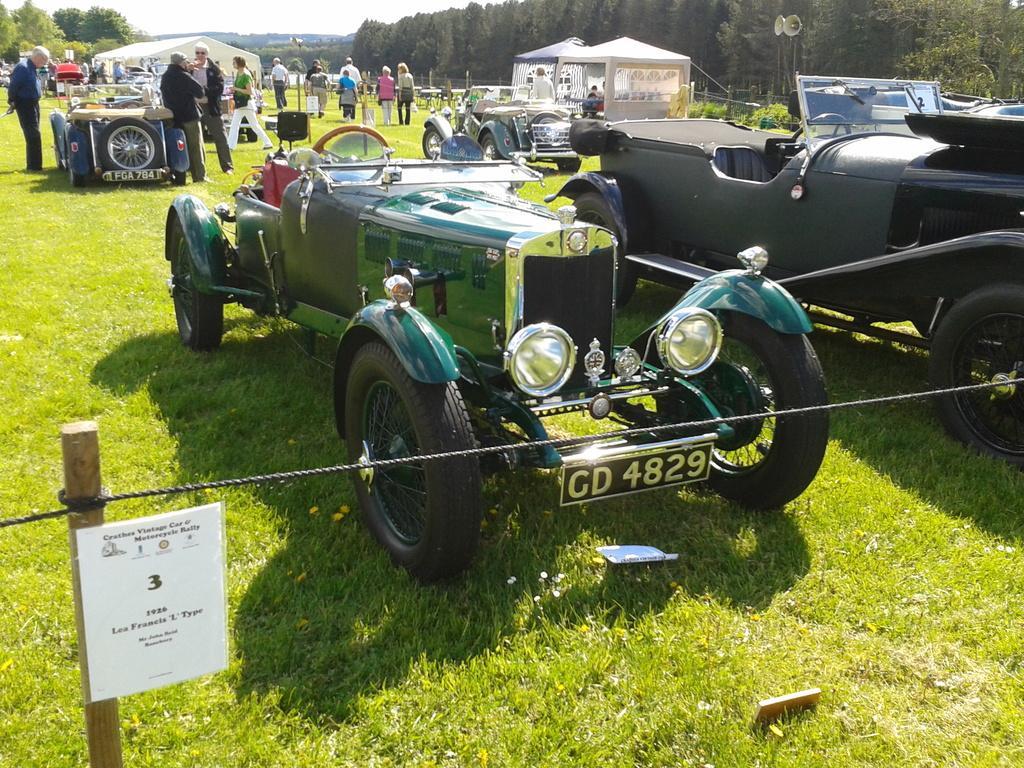Can you describe this image briefly? In this image we can see some vehicles parked on the grass. Image also consists of many people, houses, trees and also speakers. We can also see a rope to the pole. 